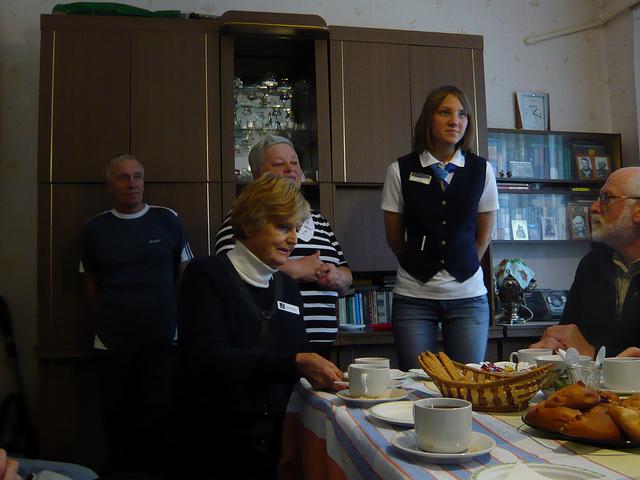Are these diners workers who are taking a lunch break?
Concise answer only. Yes. Does the man on the left have facial hair?
Answer briefly. No. Is this a holiday dinner?
Answer briefly. No. Is this a family?
Write a very short answer. No. What color is the people's hair?
Answer briefly. Multiple colors. How many bowls are there?
Give a very brief answer. 0. What is the female standing next to?
Answer briefly. Table. What color is the man's shirt?
Write a very short answer. Black. Are they having a birthday party?
Concise answer only. No. Are the people enjoying themselves?
Concise answer only. Yes. Where is the bottle of wine?
Be succinct. Cabinet. How many people in the photo?
Short answer required. 5. What is in the middle basket?
Write a very short answer. Bread. Are these people trying fermented drinks?
Answer briefly. No. How many serving bowls/dishes are on the counter?
Write a very short answer. 2. How many people are in this picture?
Answer briefly. 5. Is this a business?
Quick response, please. Yes. Is she happy?
Concise answer only. Yes. What does the woman have around her waist?
Give a very brief answer. Nothing. Who is older the girl or the boy?
Give a very brief answer. Boy. What is the name of the sign the girl is making with her hand?
Keep it brief. Nothing. Is this a fancy restaurant?
Give a very brief answer. No. Are they in a restaurant?
Be succinct. No. Will they be drinking coffee?
Give a very brief answer. Yes. Is this a hotel?
Give a very brief answer. Yes. What color is the man in the back wearing?
Answer briefly. Blue and white. What is on the shelf behind her?
Quick response, please. Glasses. Is this a fast food restaurant?
Give a very brief answer. No. What type of room is pictured in this scene?
Write a very short answer. Dining room. Is the man in the background on the left wearing a watch?
Write a very short answer. No. How many people have their glasses on?
Answer briefly. 1. Is there any light in the room?
Answer briefly. Yes. What are the women doing with the bananas?
Give a very brief answer. Nothing. What kind of kitchen is this?
Concise answer only. Home. Is the gray haired man in the background possibly overweight?
Keep it brief. No. How many people in this picture are women?
Give a very brief answer. 3. 